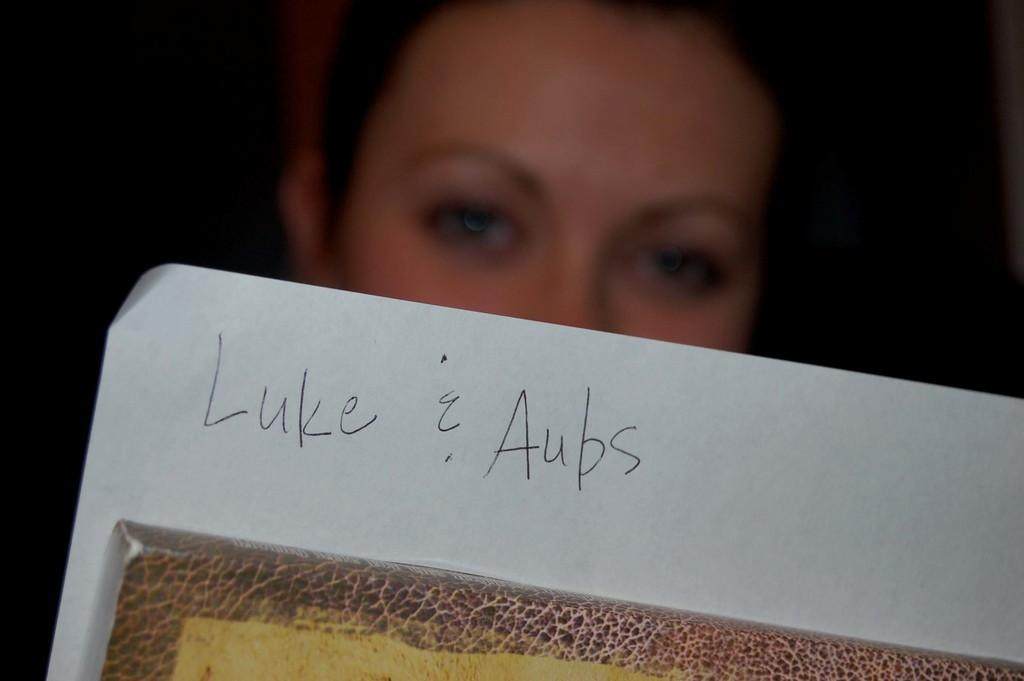Who is present in the image? There is a woman in the image. What is the woman holding in the image? The woman is holding a poster. What type of copper material is used to create the squirrel in the image? There is no copper material or squirrel present in the image. 